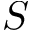Convert formula to latex. <formula><loc_0><loc_0><loc_500><loc_500>S</formula> 